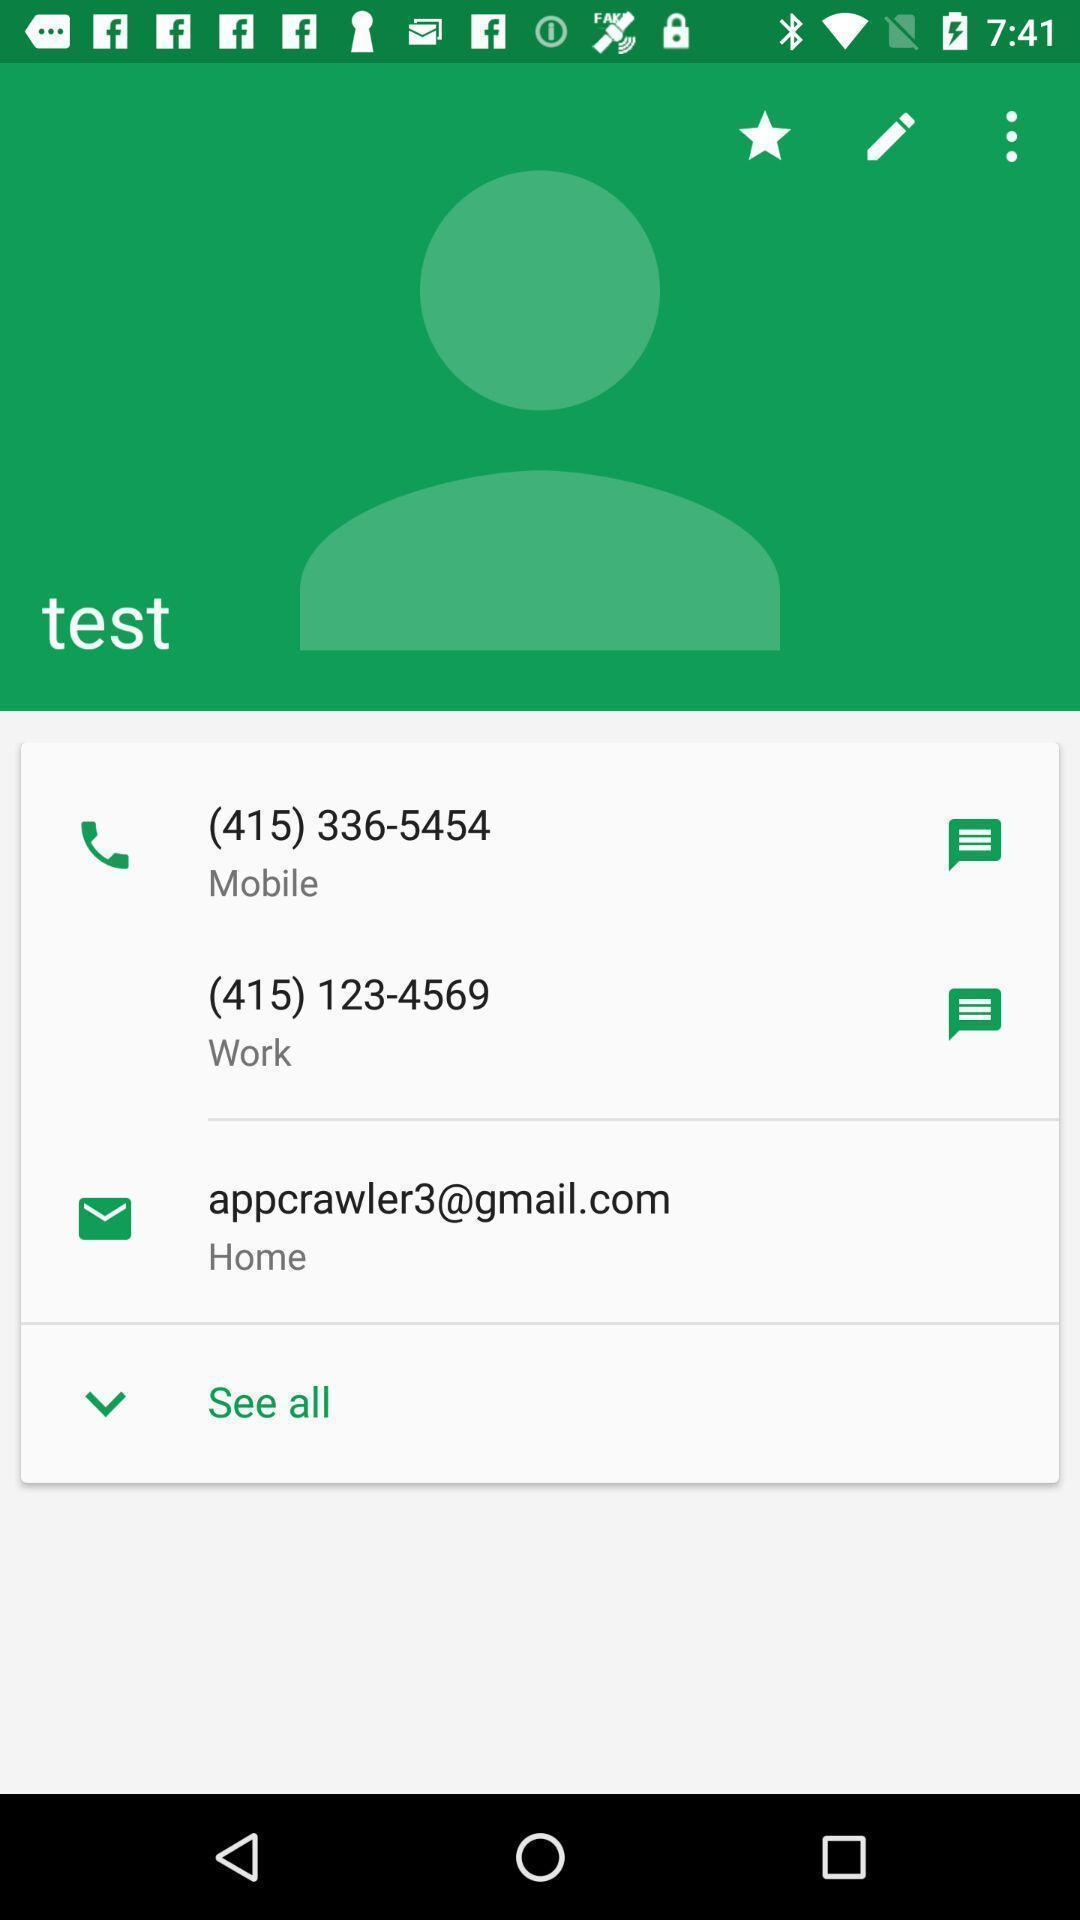Describe the visual elements of this screenshot. Page showing the multiple contacts of test with email. 